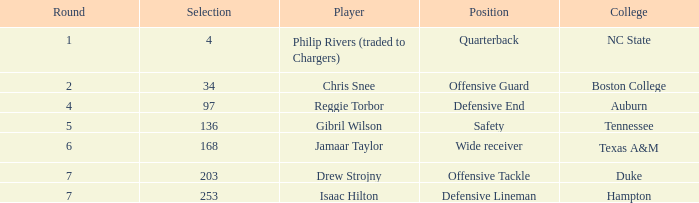Which option includes a texas a&m college? 168.0. 